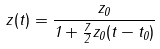Convert formula to latex. <formula><loc_0><loc_0><loc_500><loc_500>z ( t ) = \frac { z _ { 0 } } { 1 + \frac { 7 } { 2 } z _ { 0 } ( t - t _ { 0 } ) }</formula> 